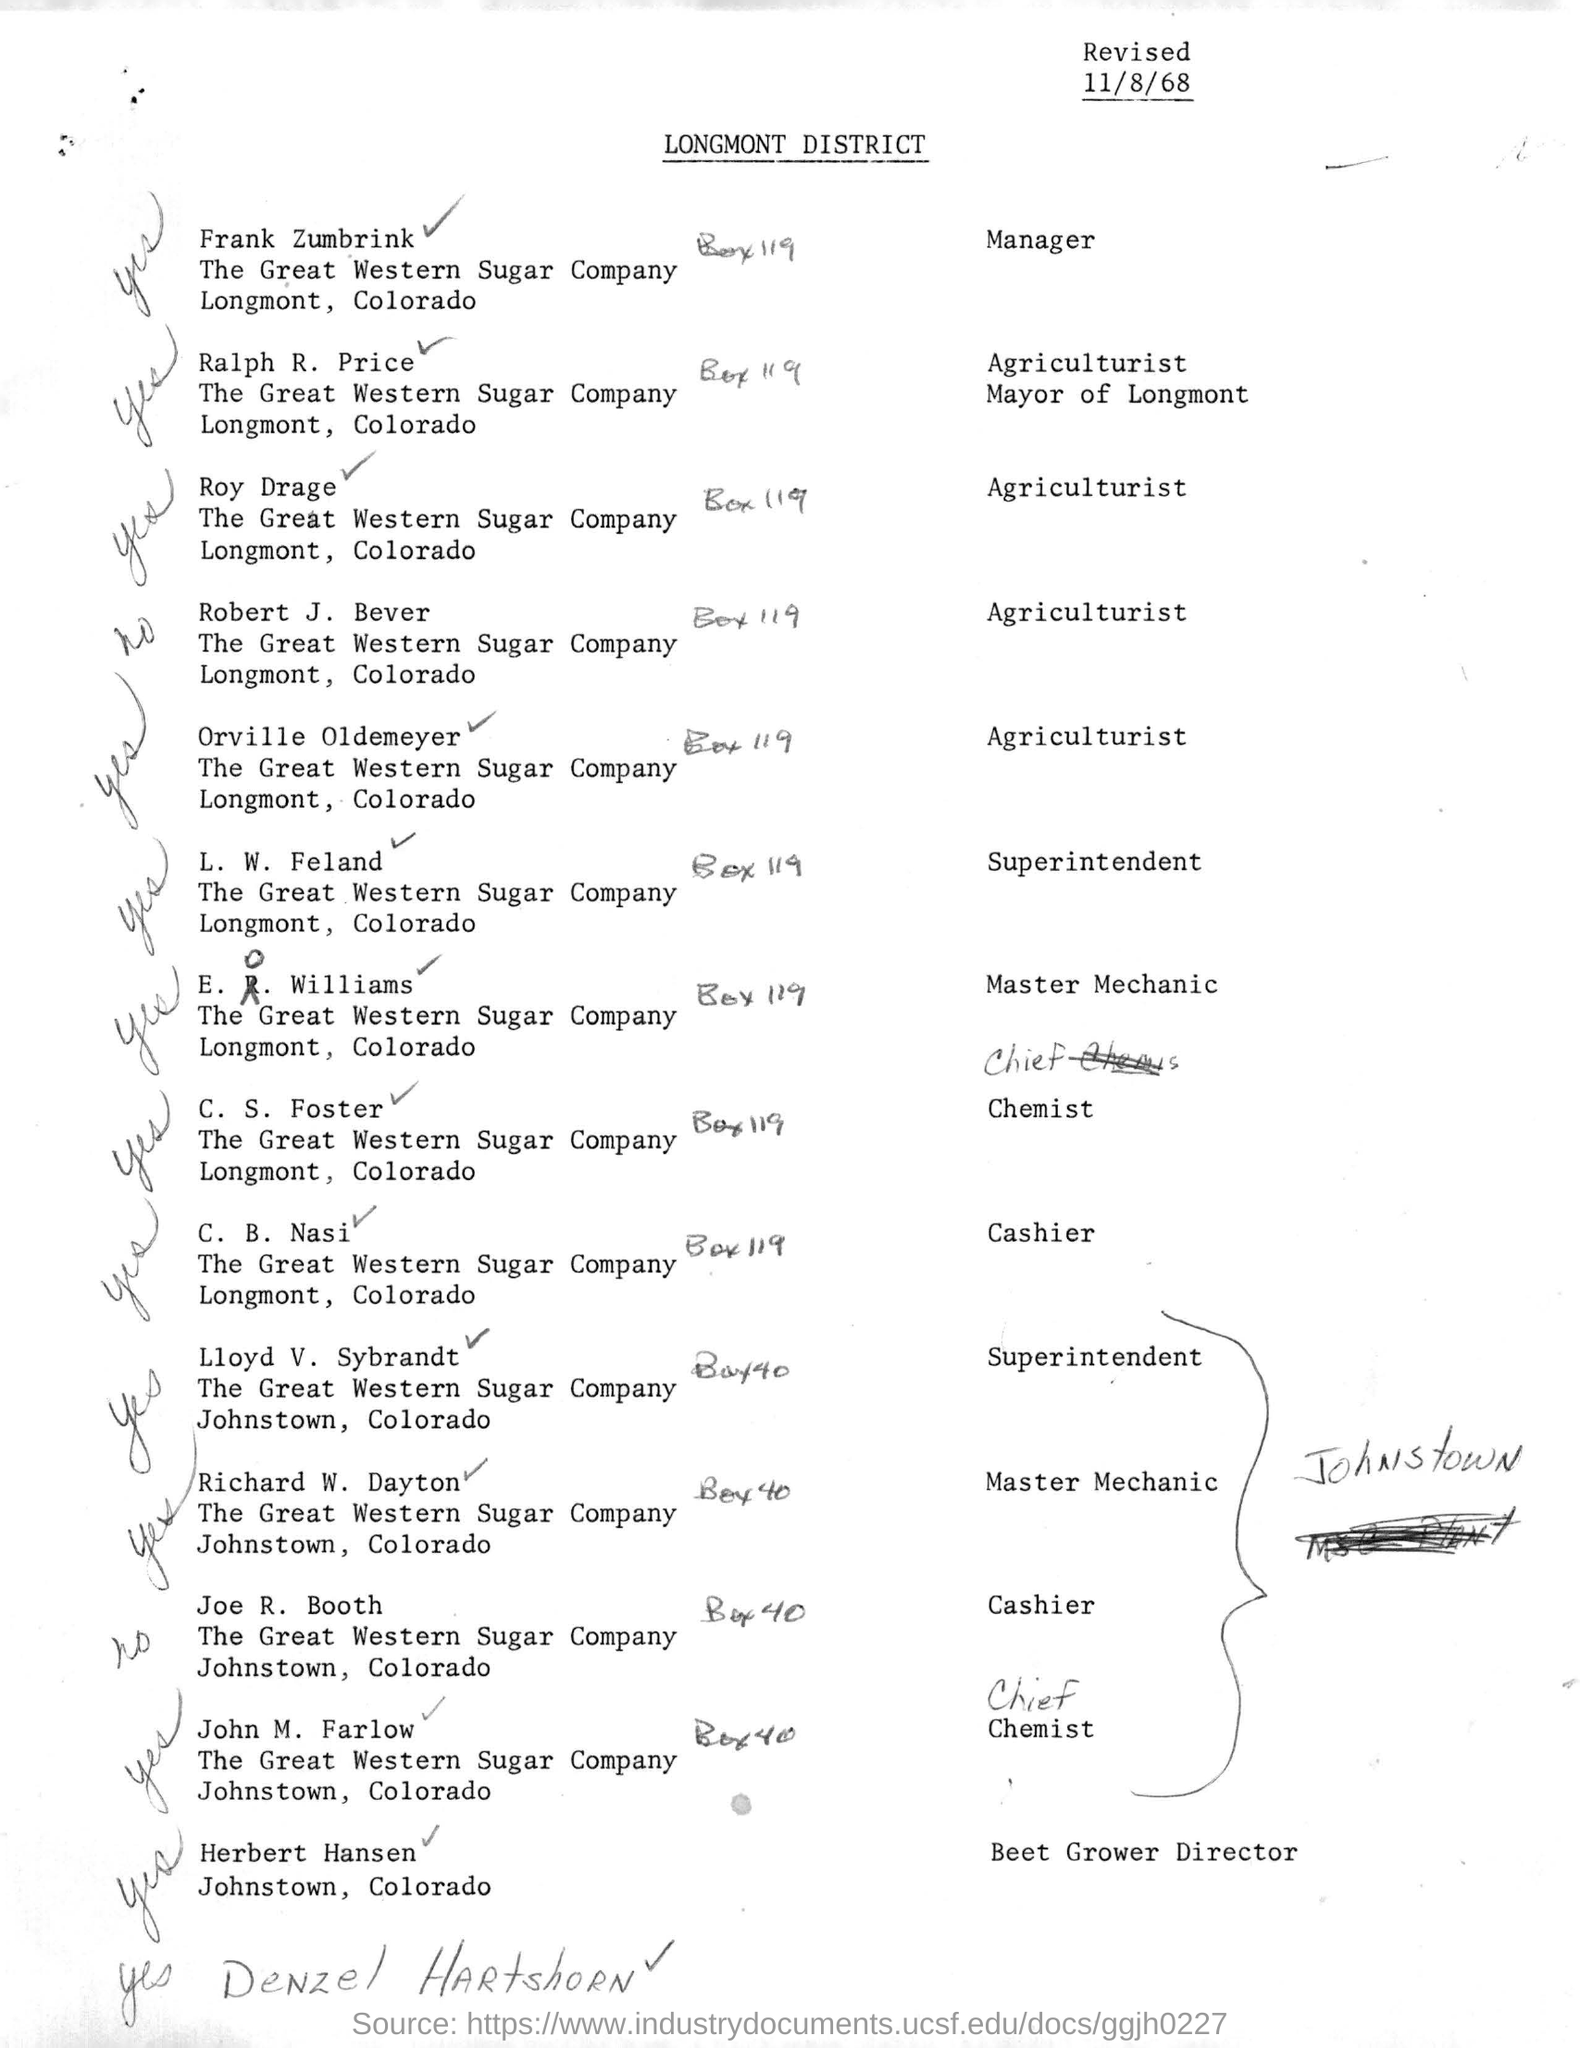Mention a couple of crucial points in this snapshot. The individual who works as a cashier at a location in Longmont, Colorado is named C. B. Nasi. The document was revised on November 8th, 1968. L.W. Feland is designated as the superintendent. 